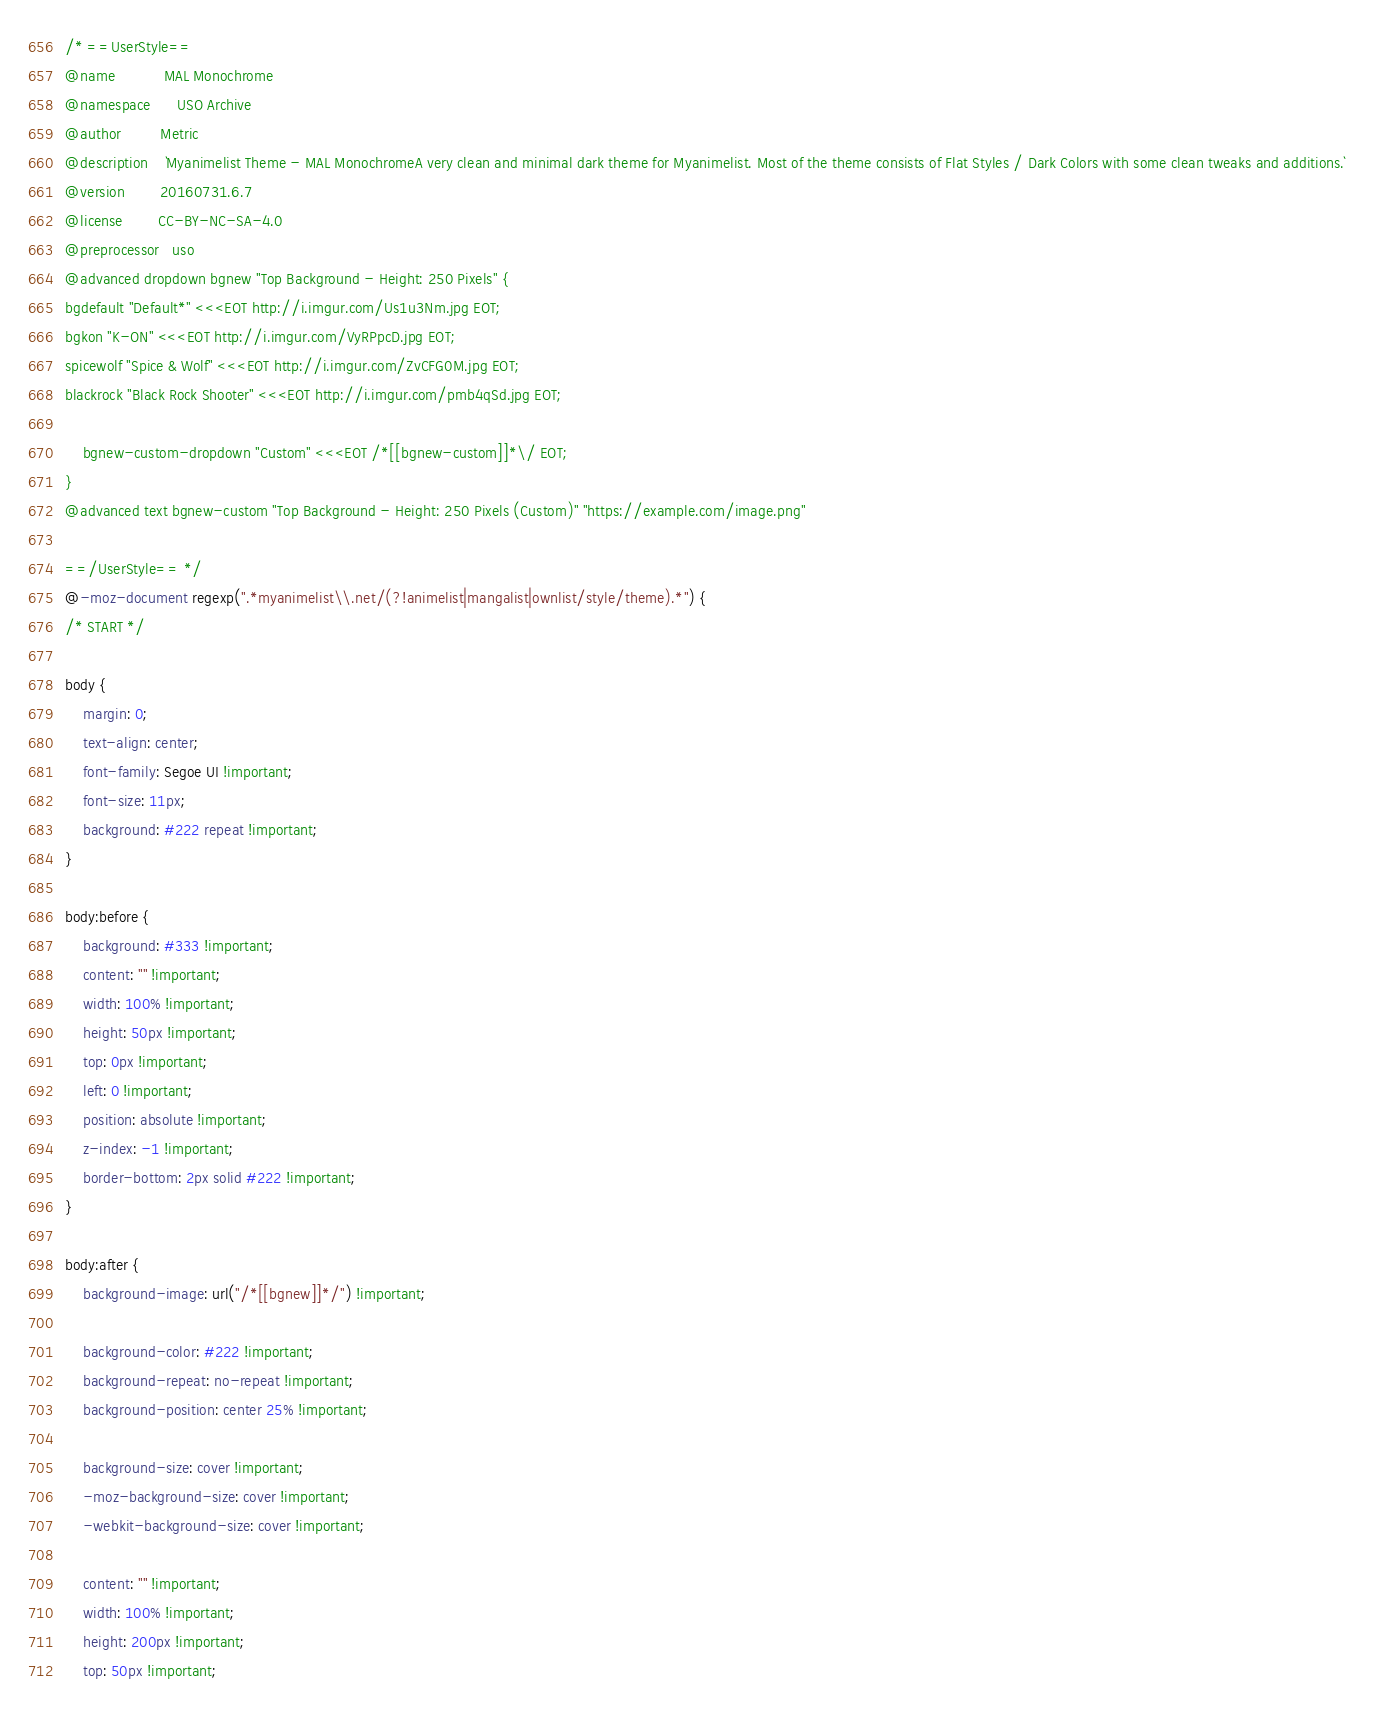<code> <loc_0><loc_0><loc_500><loc_500><_CSS_>/* ==UserStyle==
@name           MAL Monochrome
@namespace      USO Archive
@author         Metric
@description    `Myanimelist Theme - MAL MonochromeA very clean and minimal dark theme for Myanimelist. Most of the theme consists of Flat Styles / Dark Colors with some clean tweaks and additions.`
@version        20160731.6.7
@license        CC-BY-NC-SA-4.0
@preprocessor   uso
@advanced dropdown bgnew "Top Background - Height: 250 Pixels" {
bgdefault "Default*" <<<EOT http://i.imgur.com/Us1u3Nm.jpg EOT;
bgkon "K-ON" <<<EOT http://i.imgur.com/VyRPpcD.jpg EOT;
spicewolf "Spice & Wolf" <<<EOT http://i.imgur.com/ZvCFG0M.jpg EOT;
blackrock "Black Rock Shooter" <<<EOT http://i.imgur.com/pmb4qSd.jpg EOT;

	bgnew-custom-dropdown "Custom" <<<EOT /*[[bgnew-custom]]*\/ EOT;
}
@advanced text bgnew-custom "Top Background - Height: 250 Pixels (Custom)" "https://example.com/image.png"

==/UserStyle== */
@-moz-document regexp(".*myanimelist\\.net/(?!animelist|mangalist|ownlist/style/theme).*") {
/* START */

body {
	margin: 0;
	text-align: center;
	font-family: Segoe UI !important;
	font-size: 11px;
  	background: #222 repeat !important;
}

body:before {
    background: #333 !important;
    content: "" !important;
    width: 100% !important;
    height: 50px !important;
    top: 0px !important;
    left: 0 !important;
    position: absolute !important;
    z-index: -1 !important;
    border-bottom: 2px solid #222 !important;
}

body:after {
    background-image: url("/*[[bgnew]]*/") !important;
    
    background-color: #222 !important;
    background-repeat: no-repeat !important;
    background-position: center 25% !important;
    
    background-size: cover !important;
    -moz-background-size: cover !important;
    -webkit-background-size: cover !important;
    
    content: "" !important;
    width: 100% !important;
    height: 200px !important;
    top: 50px !important;</code> 